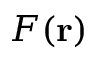<formula> <loc_0><loc_0><loc_500><loc_500>F ( r )</formula> 